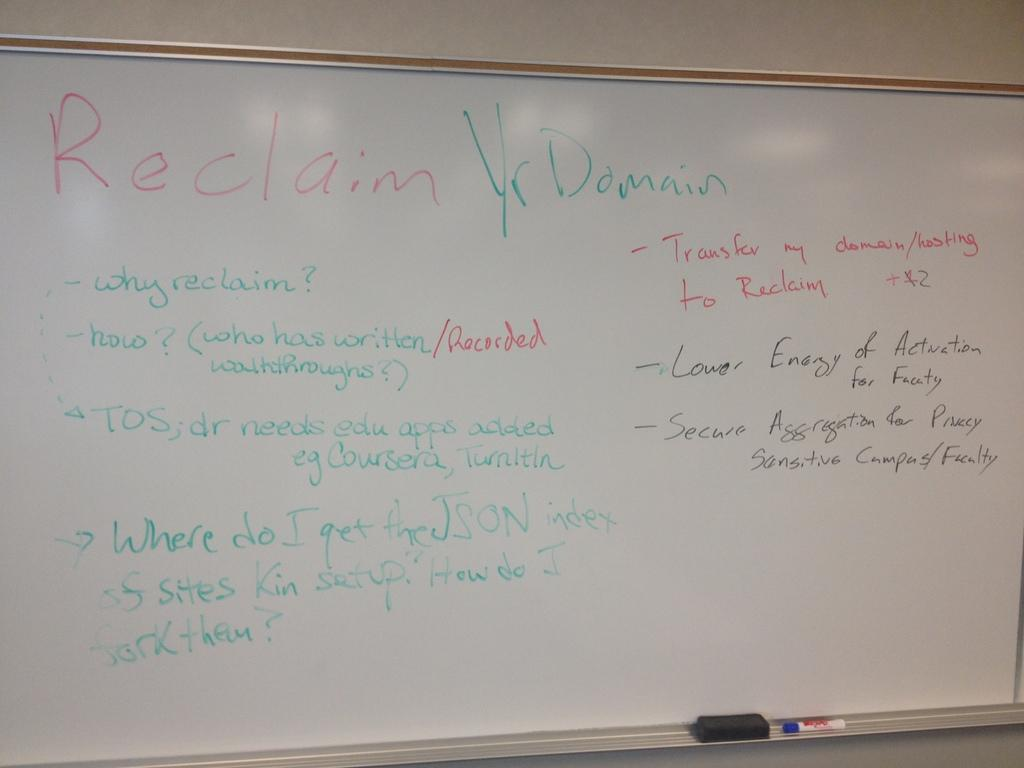<image>
Give a short and clear explanation of the subsequent image. White board in a class room that talks about reclaim yr domain 